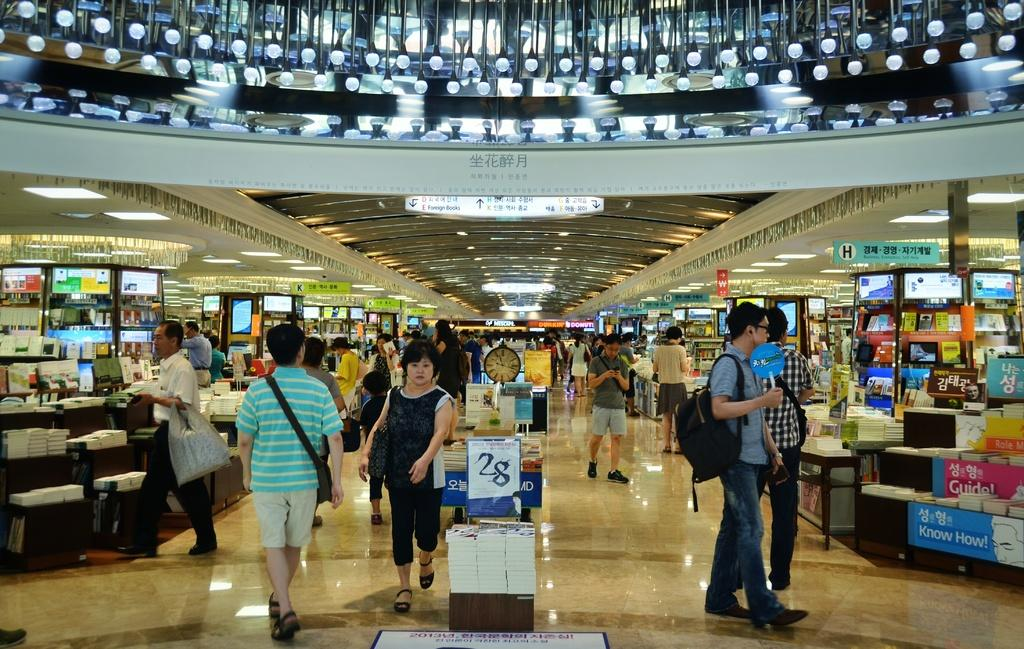<image>
Give a short and clear explanation of the subsequent image. People shopping inside a store with a numbe 28 sign on the front. 